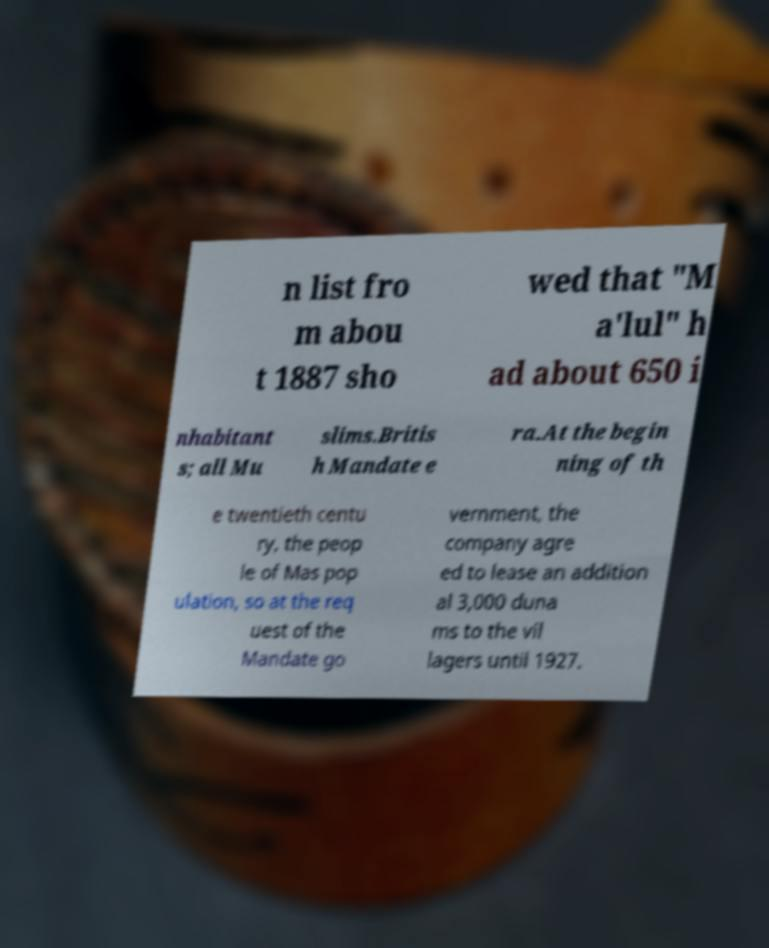Please read and relay the text visible in this image. What does it say? n list fro m abou t 1887 sho wed that "M a'lul" h ad about 650 i nhabitant s; all Mu slims.Britis h Mandate e ra.At the begin ning of th e twentieth centu ry, the peop le of Mas pop ulation, so at the req uest of the Mandate go vernment, the company agre ed to lease an addition al 3,000 duna ms to the vil lagers until 1927. 